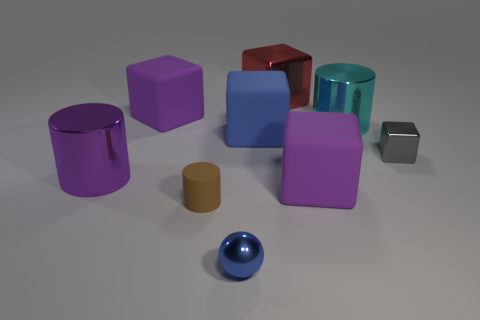Add 1 purple cylinders. How many objects exist? 10 Subtract all large cylinders. How many cylinders are left? 1 Subtract 2 cylinders. How many cylinders are left? 1 Subtract all yellow cylinders. Subtract all yellow balls. How many cylinders are left? 3 Subtract all purple blocks. How many gray cylinders are left? 0 Add 6 large purple metal things. How many large purple metal things are left? 7 Add 9 brown rubber things. How many brown rubber things exist? 10 Subtract all cyan cylinders. How many cylinders are left? 2 Subtract 2 purple cubes. How many objects are left? 7 Subtract all cubes. How many objects are left? 4 